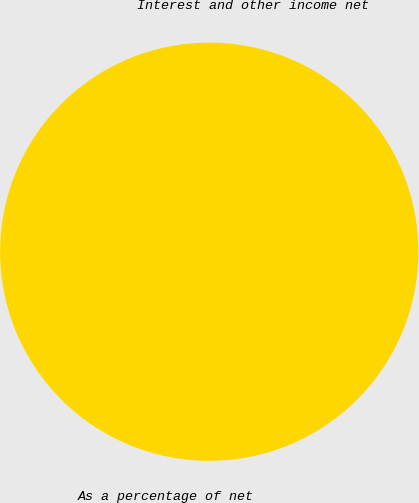Convert chart. <chart><loc_0><loc_0><loc_500><loc_500><pie_chart><fcel>Interest and other income net<fcel>As a percentage of net<nl><fcel>100.0%<fcel>0.0%<nl></chart> 